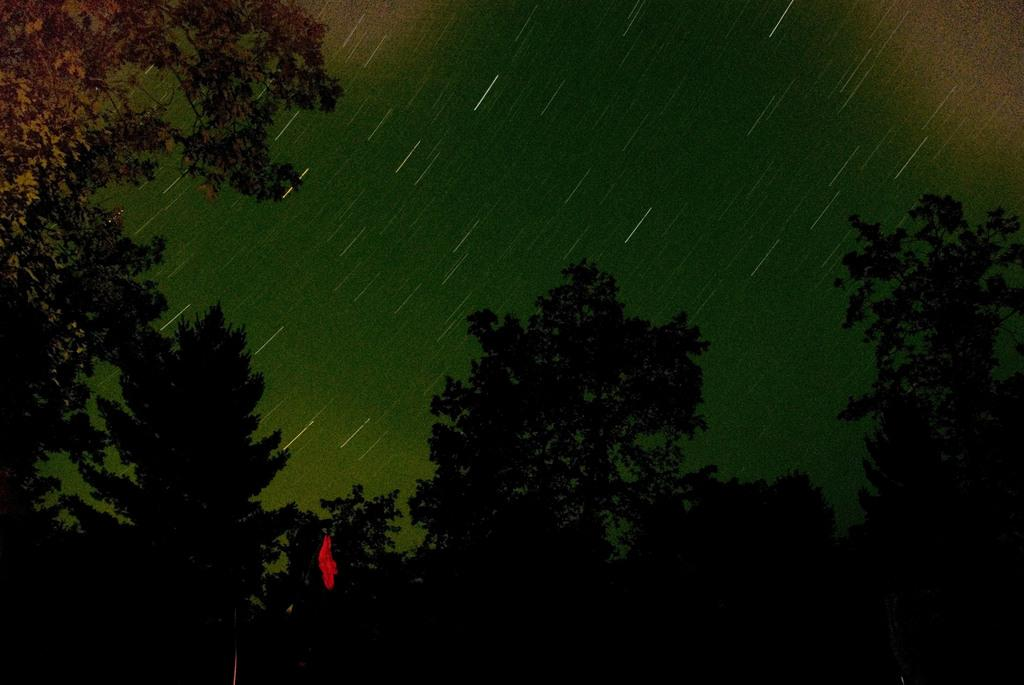What is located at the front of the image? There are trees in the front of the image. Can you describe any characteristics of the image? The image appears to be edited. Can you see an airplane flying over the trees in the image? There is no airplane visible in the image; it only features trees at the front. What type of bit is being used to edit the image? The fact provided does not mention any specific editing tools or techniques, so it is not possible to determine the type of bit used. 